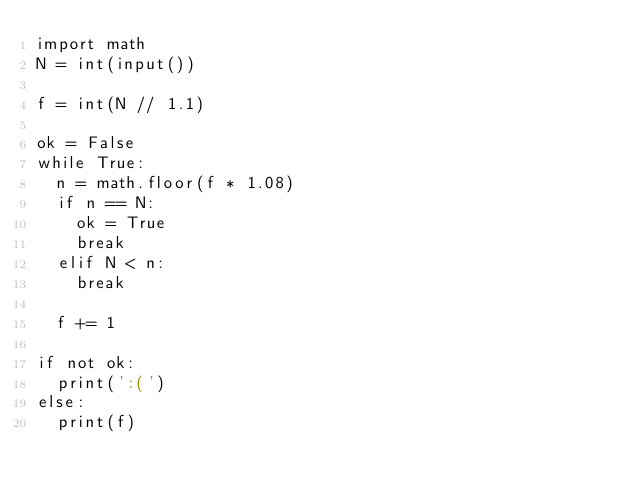Convert code to text. <code><loc_0><loc_0><loc_500><loc_500><_Python_>import math
N = int(input())

f = int(N // 1.1)

ok = False
while True:
  n = math.floor(f * 1.08)
  if n == N:
    ok = True
    break
  elif N < n:
    break
    
  f += 1
  
if not ok:
  print(':(')
else:
  print(f)
  
</code> 